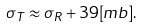Convert formula to latex. <formula><loc_0><loc_0><loc_500><loc_500>\sigma _ { T } \approx \sigma _ { R } + 3 9 [ m b ] .</formula> 